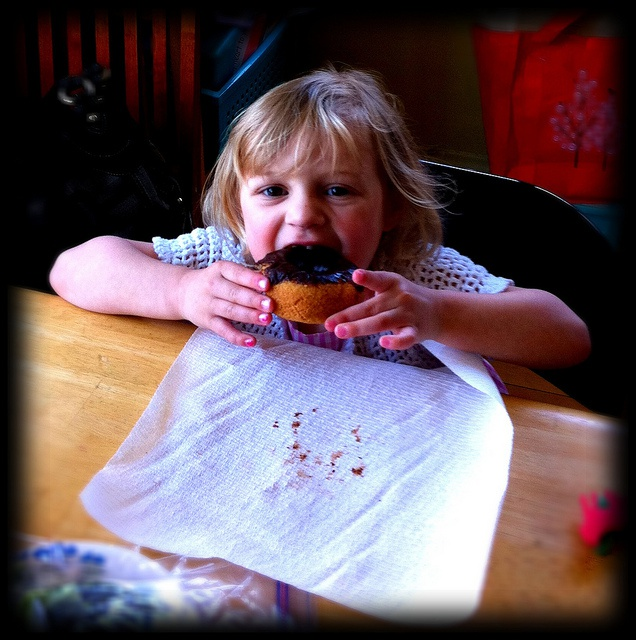Describe the objects in this image and their specific colors. I can see dining table in black, lavender, and gray tones, people in black, maroon, lavender, and brown tones, chair in black, gray, and maroon tones, handbag in black, gray, darkgray, and maroon tones, and donut in black, maroon, brown, and red tones in this image. 